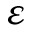<formula> <loc_0><loc_0><loc_500><loc_500>\varepsilon</formula> 